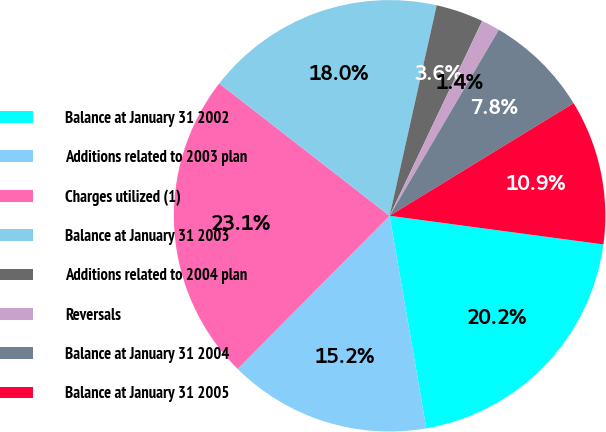Convert chart to OTSL. <chart><loc_0><loc_0><loc_500><loc_500><pie_chart><fcel>Balance at January 31 2002<fcel>Additions related to 2003 plan<fcel>Charges utilized (1)<fcel>Balance at January 31 2003<fcel>Additions related to 2004 plan<fcel>Reversals<fcel>Balance at January 31 2004<fcel>Balance at January 31 2005<nl><fcel>20.16%<fcel>15.16%<fcel>23.08%<fcel>17.99%<fcel>3.56%<fcel>1.39%<fcel>7.81%<fcel>10.86%<nl></chart> 